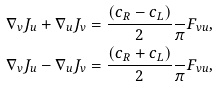<formula> <loc_0><loc_0><loc_500><loc_500>\nabla _ { v } J _ { u } + \nabla _ { u } J _ { v } & = \frac { ( c _ { R } - c _ { L } ) } { 2 } \frac { } { \pi } F _ { v u } , \\ \nabla _ { v } J _ { u } - \nabla _ { u } J _ { v } & = \frac { ( c _ { R } + c _ { L } ) } { 2 } \frac { } { \pi } F _ { v u } ,</formula> 